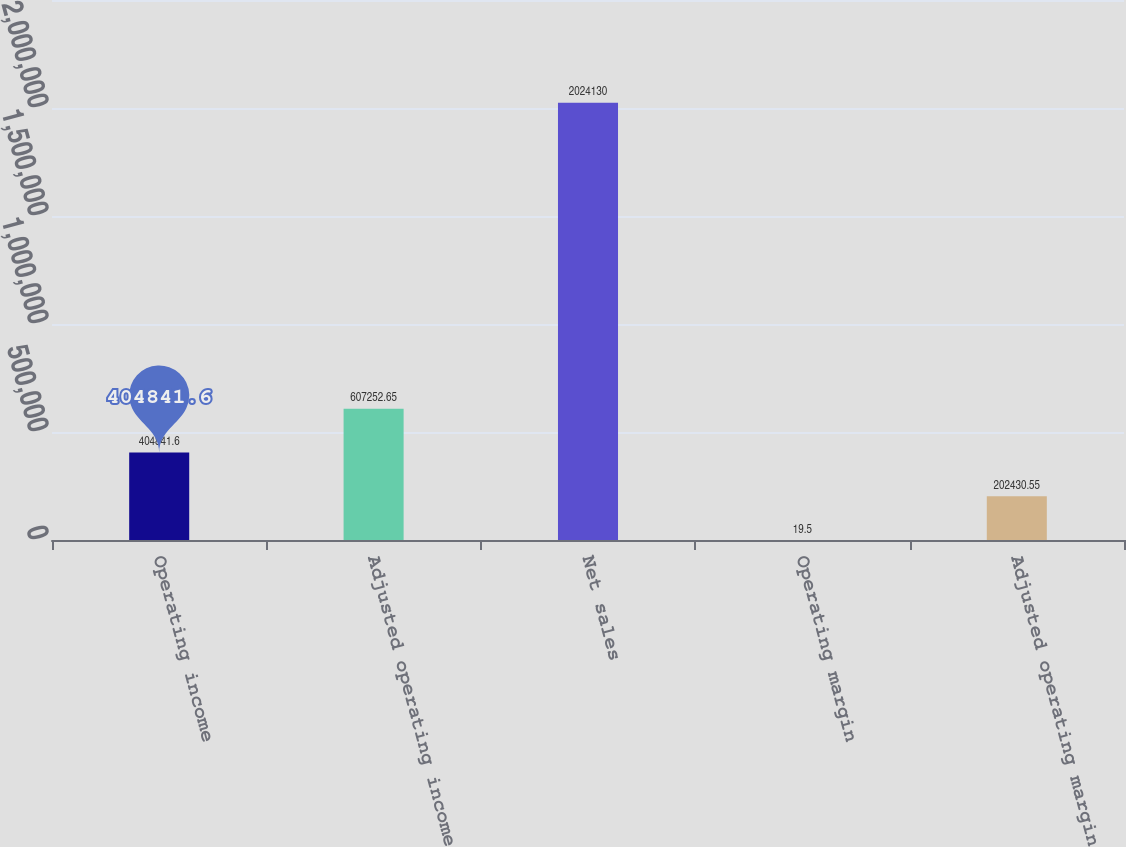Convert chart to OTSL. <chart><loc_0><loc_0><loc_500><loc_500><bar_chart><fcel>Operating income<fcel>Adjusted operating income<fcel>Net sales<fcel>Operating margin<fcel>Adjusted operating margin<nl><fcel>404842<fcel>607253<fcel>2.02413e+06<fcel>19.5<fcel>202431<nl></chart> 